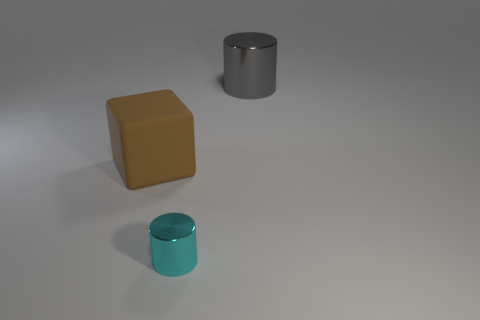Subtract all cubes. How many objects are left? 2 Add 1 tiny metallic cylinders. How many objects exist? 4 Add 1 spheres. How many spheres exist? 1 Subtract 0 red balls. How many objects are left? 3 Subtract all gray metal objects. Subtract all large metal cylinders. How many objects are left? 1 Add 3 tiny cyan metal things. How many tiny cyan metal things are left? 4 